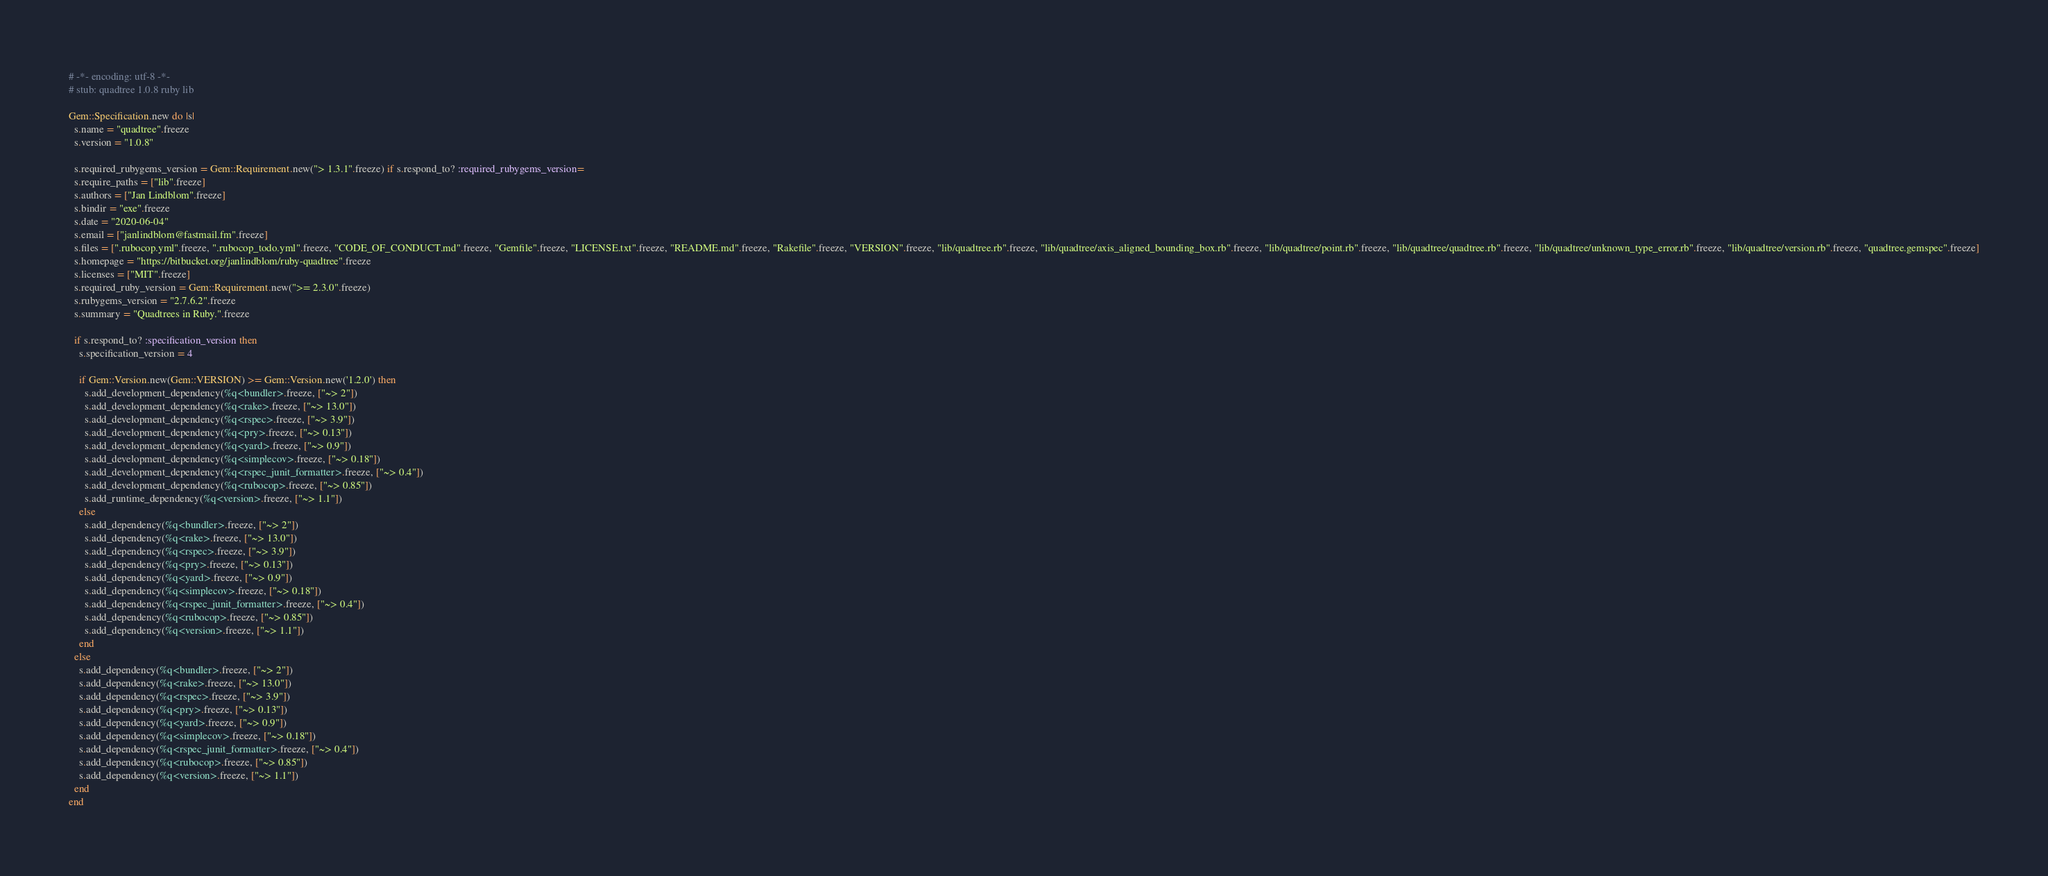<code> <loc_0><loc_0><loc_500><loc_500><_Ruby_># -*- encoding: utf-8 -*-
# stub: quadtree 1.0.8 ruby lib

Gem::Specification.new do |s|
  s.name = "quadtree".freeze
  s.version = "1.0.8"

  s.required_rubygems_version = Gem::Requirement.new("> 1.3.1".freeze) if s.respond_to? :required_rubygems_version=
  s.require_paths = ["lib".freeze]
  s.authors = ["Jan Lindblom".freeze]
  s.bindir = "exe".freeze
  s.date = "2020-06-04"
  s.email = ["janlindblom@fastmail.fm".freeze]
  s.files = [".rubocop.yml".freeze, ".rubocop_todo.yml".freeze, "CODE_OF_CONDUCT.md".freeze, "Gemfile".freeze, "LICENSE.txt".freeze, "README.md".freeze, "Rakefile".freeze, "VERSION".freeze, "lib/quadtree.rb".freeze, "lib/quadtree/axis_aligned_bounding_box.rb".freeze, "lib/quadtree/point.rb".freeze, "lib/quadtree/quadtree.rb".freeze, "lib/quadtree/unknown_type_error.rb".freeze, "lib/quadtree/version.rb".freeze, "quadtree.gemspec".freeze]
  s.homepage = "https://bitbucket.org/janlindblom/ruby-quadtree".freeze
  s.licenses = ["MIT".freeze]
  s.required_ruby_version = Gem::Requirement.new(">= 2.3.0".freeze)
  s.rubygems_version = "2.7.6.2".freeze
  s.summary = "Quadtrees in Ruby.".freeze

  if s.respond_to? :specification_version then
    s.specification_version = 4

    if Gem::Version.new(Gem::VERSION) >= Gem::Version.new('1.2.0') then
      s.add_development_dependency(%q<bundler>.freeze, ["~> 2"])
      s.add_development_dependency(%q<rake>.freeze, ["~> 13.0"])
      s.add_development_dependency(%q<rspec>.freeze, ["~> 3.9"])
      s.add_development_dependency(%q<pry>.freeze, ["~> 0.13"])
      s.add_development_dependency(%q<yard>.freeze, ["~> 0.9"])
      s.add_development_dependency(%q<simplecov>.freeze, ["~> 0.18"])
      s.add_development_dependency(%q<rspec_junit_formatter>.freeze, ["~> 0.4"])
      s.add_development_dependency(%q<rubocop>.freeze, ["~> 0.85"])
      s.add_runtime_dependency(%q<version>.freeze, ["~> 1.1"])
    else
      s.add_dependency(%q<bundler>.freeze, ["~> 2"])
      s.add_dependency(%q<rake>.freeze, ["~> 13.0"])
      s.add_dependency(%q<rspec>.freeze, ["~> 3.9"])
      s.add_dependency(%q<pry>.freeze, ["~> 0.13"])
      s.add_dependency(%q<yard>.freeze, ["~> 0.9"])
      s.add_dependency(%q<simplecov>.freeze, ["~> 0.18"])
      s.add_dependency(%q<rspec_junit_formatter>.freeze, ["~> 0.4"])
      s.add_dependency(%q<rubocop>.freeze, ["~> 0.85"])
      s.add_dependency(%q<version>.freeze, ["~> 1.1"])
    end
  else
    s.add_dependency(%q<bundler>.freeze, ["~> 2"])
    s.add_dependency(%q<rake>.freeze, ["~> 13.0"])
    s.add_dependency(%q<rspec>.freeze, ["~> 3.9"])
    s.add_dependency(%q<pry>.freeze, ["~> 0.13"])
    s.add_dependency(%q<yard>.freeze, ["~> 0.9"])
    s.add_dependency(%q<simplecov>.freeze, ["~> 0.18"])
    s.add_dependency(%q<rspec_junit_formatter>.freeze, ["~> 0.4"])
    s.add_dependency(%q<rubocop>.freeze, ["~> 0.85"])
    s.add_dependency(%q<version>.freeze, ["~> 1.1"])
  end
end
</code> 